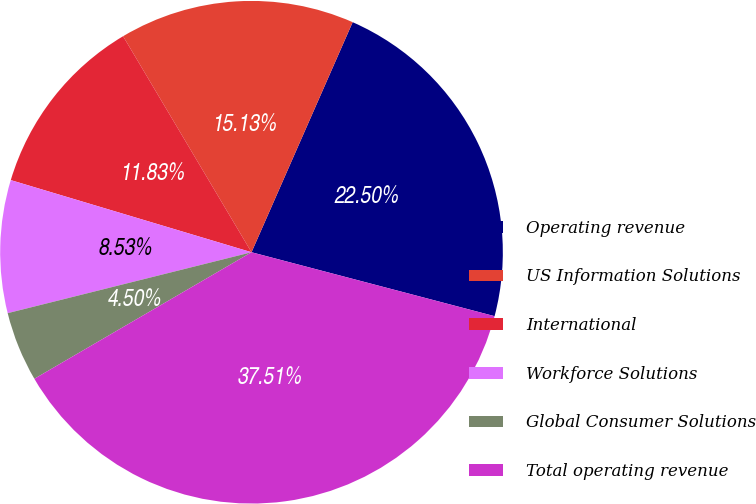Convert chart to OTSL. <chart><loc_0><loc_0><loc_500><loc_500><pie_chart><fcel>Operating revenue<fcel>US Information Solutions<fcel>International<fcel>Workforce Solutions<fcel>Global Consumer Solutions<fcel>Total operating revenue<nl><fcel>22.5%<fcel>15.13%<fcel>11.83%<fcel>8.53%<fcel>4.5%<fcel>37.51%<nl></chart> 